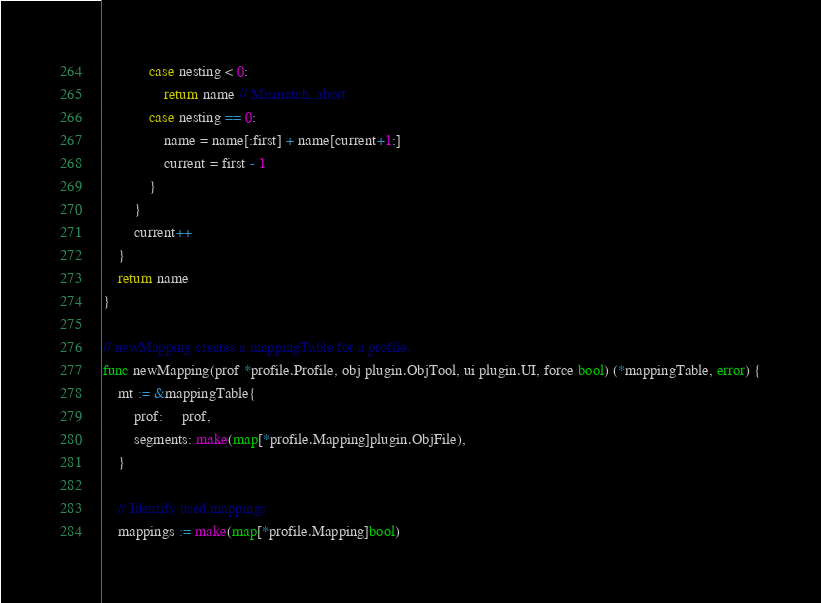<code> <loc_0><loc_0><loc_500><loc_500><_Go_>			case nesting < 0:
				return name // Mismatch, abort
			case nesting == 0:
				name = name[:first] + name[current+1:]
				current = first - 1
			}
		}
		current++
	}
	return name
}

// newMapping creates a mappingTable for a profile.
func newMapping(prof *profile.Profile, obj plugin.ObjTool, ui plugin.UI, force bool) (*mappingTable, error) {
	mt := &mappingTable{
		prof:     prof,
		segments: make(map[*profile.Mapping]plugin.ObjFile),
	}

	// Identify used mappings
	mappings := make(map[*profile.Mapping]bool)</code> 